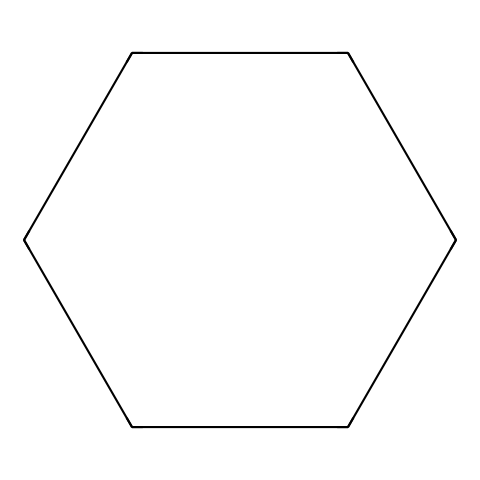What is the molecular formula of cyclohexane? To determine the molecular formula, count the number of carbon (C) and hydrogen (H) atoms in the structure. There are six carbon atoms (C) and twelve hydrogen atoms (H) in cyclohexane. Therefore, the formula is C6H12.
Answer: C6H12 How many carbon atoms are in the structure? The SMILES representation indicates a cyclic structure with six carbon atoms (C1CCCCC1). Each "C" represents a carbon atom, and there are six such tokens in the representation.
Answer: 6 What type of bonds are present between the carbon atoms? In cyclohexane, each carbon atom is bonded to two adjacent carbon atoms through single covalent bonds. The nature of these connections can be derived from the lack of double bonds in the cyclic structure, indicating all bonds are single.
Answer: single bonds What is the hybridization of the carbon atoms in this chemical? Each carbon atom in cyclohexane is bonded to three other atoms (either other carbon or hydrogen) in a tetrahedral arrangement, which corresponds to sp3 hybridization. Because of their arrangement in a ring structure, this remains consistent.
Answer: sp3 How many hydrogen atoms are each carbon atom bonded to? In cyclohexane, each carbon atom is bonded to two other carbon atoms and two hydrogen atoms, leading to a total of two hydrogens for each carbon atom since every carbon is tetravalent (four bonds total).
Answer: 2 What is the characteristic shape of cyclohexane when it is free from strain? Cyclohexane, in its most stable form, adopts a chair conformation. This structure minimizes steric strain and torsional strain by allowing for staggered conformations of hydrogens, resulting in a lower energy state for the molecule.
Answer: chair conformation 